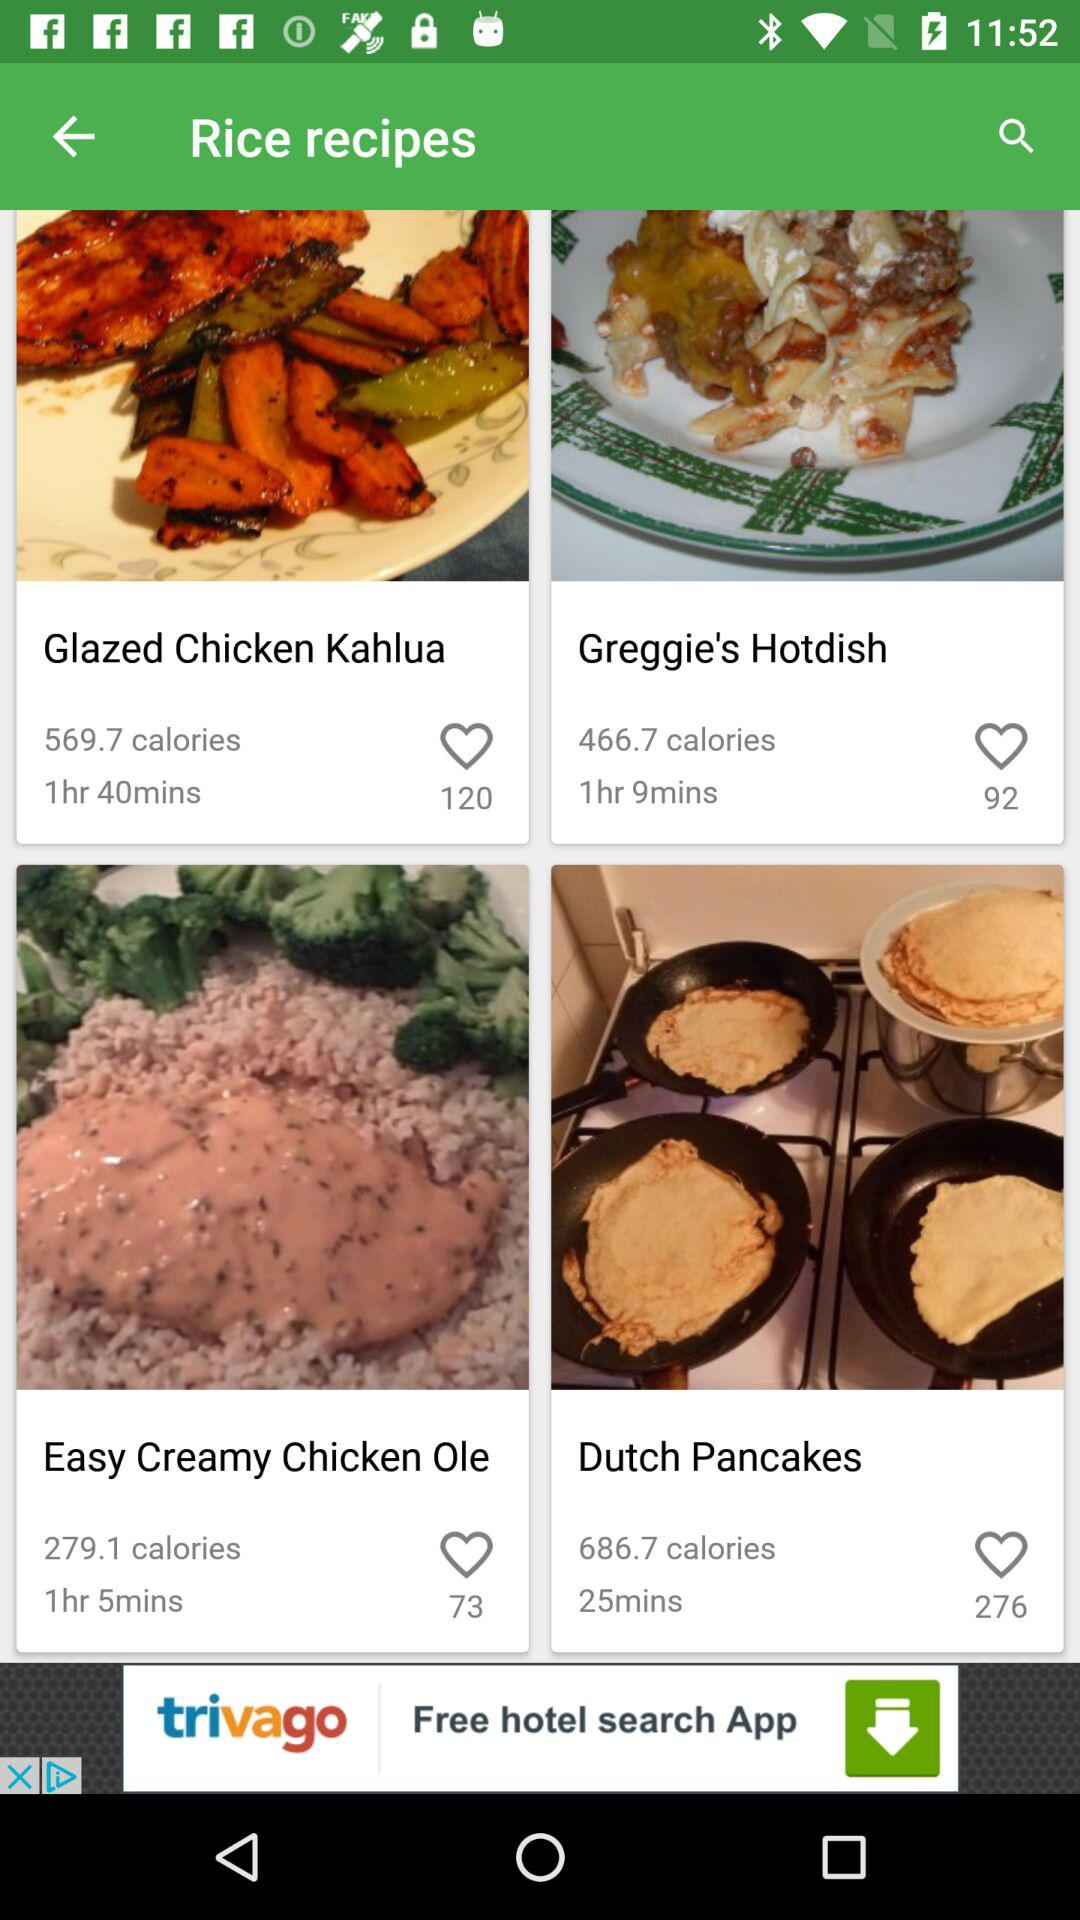How much time is required to prepare "Glazed Chicken Kahlua"? The time required to prepare "Glazed Chicken Kahlua" is 1 hour 40 minutes. 